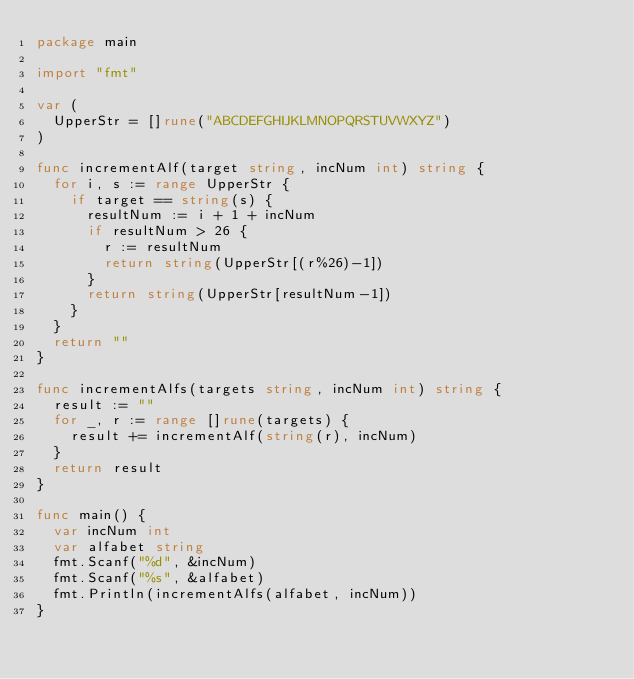<code> <loc_0><loc_0><loc_500><loc_500><_Go_>package main

import "fmt"

var (
	UpperStr = []rune("ABCDEFGHIJKLMNOPQRSTUVWXYZ")
)

func incrementAlf(target string, incNum int) string {
	for i, s := range UpperStr {
		if target == string(s) {
			resultNum := i + 1 + incNum
			if resultNum > 26 {
				r := resultNum
				return string(UpperStr[(r%26)-1])
			}
			return string(UpperStr[resultNum-1])
		}
	}
	return ""
}

func incrementAlfs(targets string, incNum int) string {
	result := ""
	for _, r := range []rune(targets) {
		result += incrementAlf(string(r), incNum)
	}
	return result
}

func main() {
	var incNum int
	var alfabet string
	fmt.Scanf("%d", &incNum)
	fmt.Scanf("%s", &alfabet)
	fmt.Println(incrementAlfs(alfabet, incNum))
}
</code> 